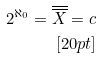Convert formula to latex. <formula><loc_0><loc_0><loc_500><loc_500>2 ^ { \aleph _ { 0 } } = \overline { \overline { X } } = c \\ [ 2 0 p t ]</formula> 